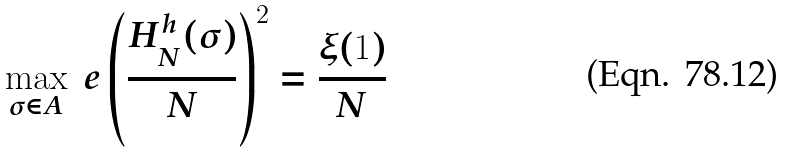<formula> <loc_0><loc_0><loc_500><loc_500>\max _ { \sigma \in A } \ e \left ( \frac { H _ { N } ^ { h } ( \sigma ) } { N } \right ) ^ { 2 } & = \frac { \xi ( 1 ) } { N }</formula> 